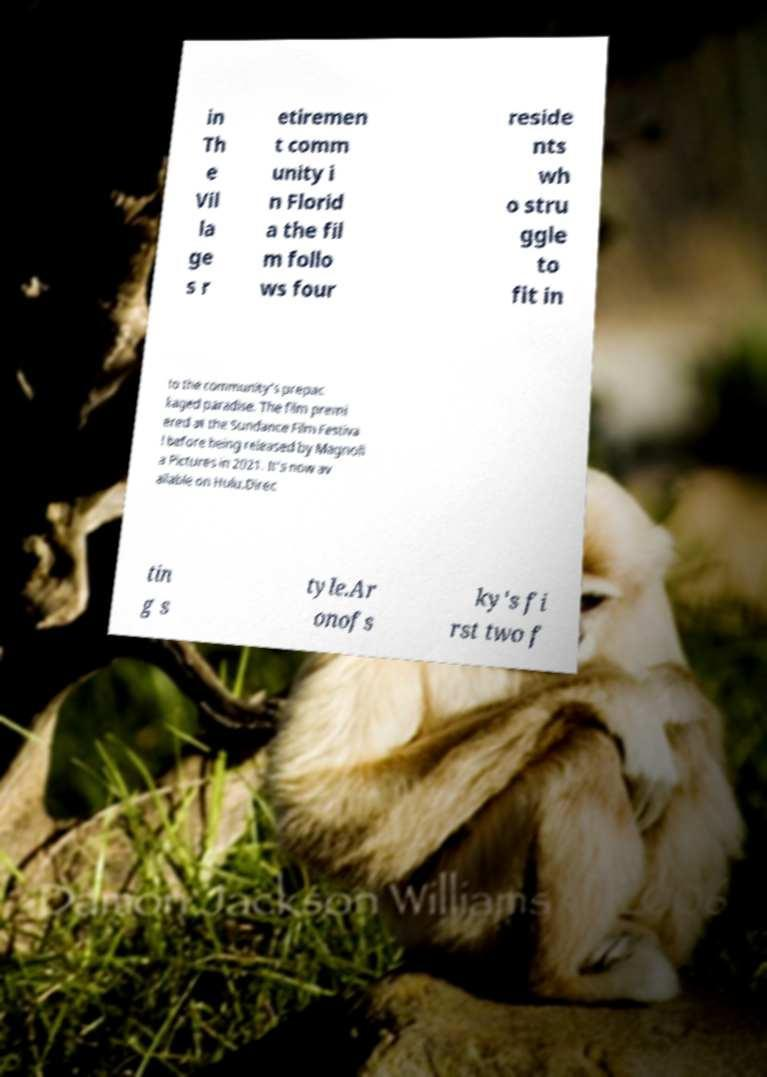Can you accurately transcribe the text from the provided image for me? in Th e Vil la ge s r etiremen t comm unity i n Florid a the fil m follo ws four reside nts wh o stru ggle to fit in to the community's prepac kaged paradise. The film premi ered at the Sundance Film Festiva l before being released by Magnoli a Pictures in 2021. It's now av ailable on Hulu.Direc tin g s tyle.Ar onofs ky's fi rst two f 